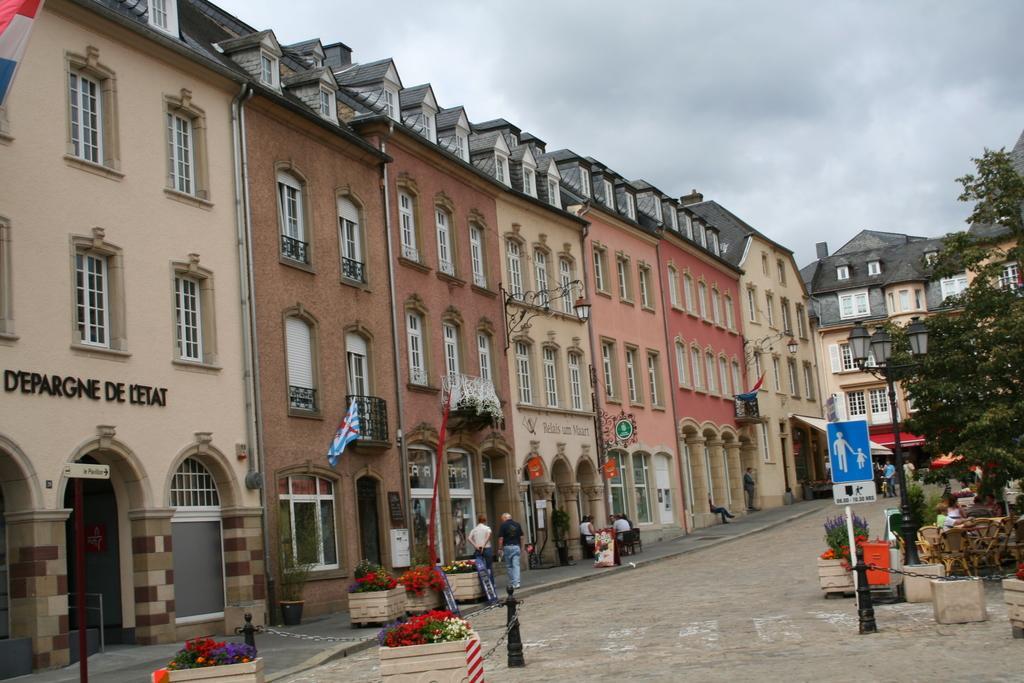In one or two sentences, can you explain what this image depicts? In this image we can see a few buildings, there are some flower pots, windows, trees, poles, flags, chairs and people, in the background, we can see the sky. 